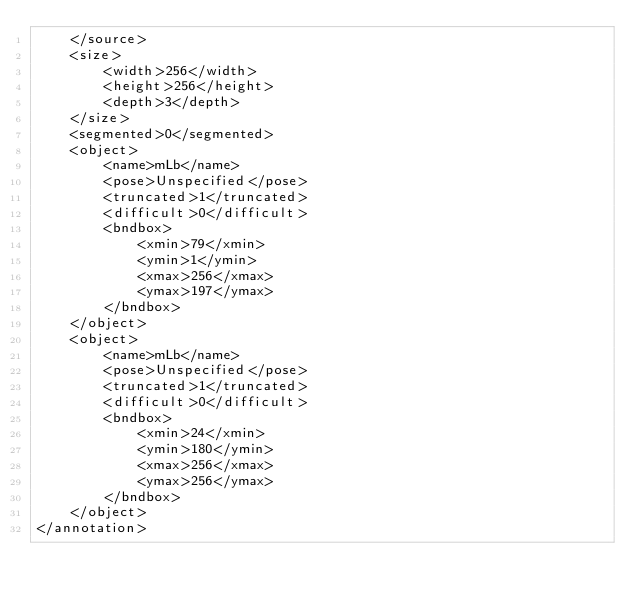Convert code to text. <code><loc_0><loc_0><loc_500><loc_500><_XML_>	</source>
	<size>
		<width>256</width>
		<height>256</height>
		<depth>3</depth>
	</size>
	<segmented>0</segmented>
	<object>
		<name>mLb</name>
		<pose>Unspecified</pose>
		<truncated>1</truncated>
		<difficult>0</difficult>
		<bndbox>
			<xmin>79</xmin>
			<ymin>1</ymin>
			<xmax>256</xmax>
			<ymax>197</ymax>
		</bndbox>
	</object>
	<object>
		<name>mLb</name>
		<pose>Unspecified</pose>
		<truncated>1</truncated>
		<difficult>0</difficult>
		<bndbox>
			<xmin>24</xmin>
			<ymin>180</ymin>
			<xmax>256</xmax>
			<ymax>256</ymax>
		</bndbox>
	</object>
</annotation>
</code> 